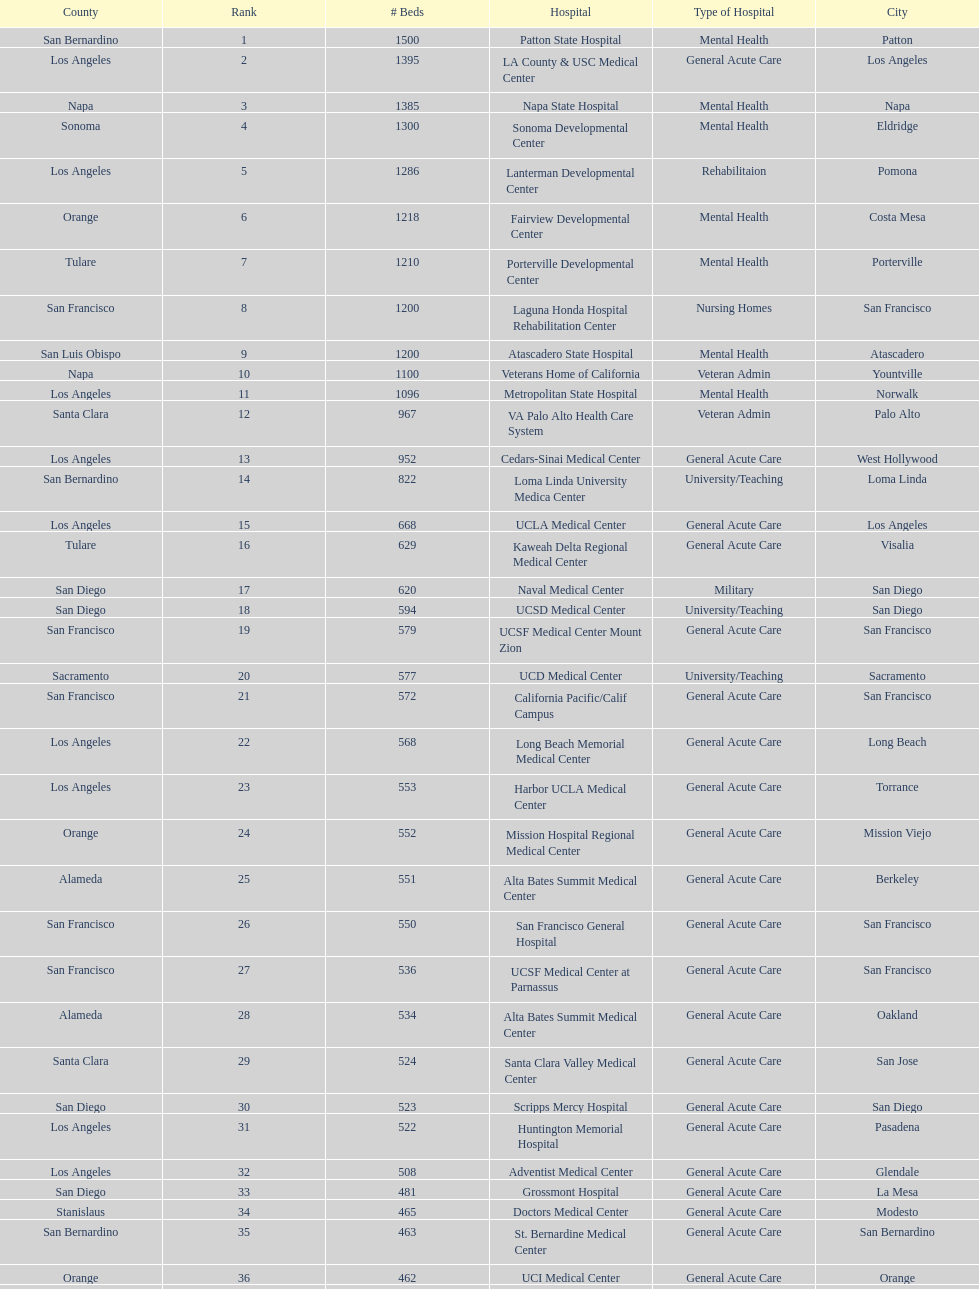Help me parse the entirety of this table. {'header': ['County', 'Rank', '# Beds', 'Hospital', 'Type of Hospital', 'City'], 'rows': [['San Bernardino', '1', '1500', 'Patton State Hospital', 'Mental Health', 'Patton'], ['Los Angeles', '2', '1395', 'LA County & USC Medical Center', 'General Acute Care', 'Los Angeles'], ['Napa', '3', '1385', 'Napa State Hospital', 'Mental Health', 'Napa'], ['Sonoma', '4', '1300', 'Sonoma Developmental Center', 'Mental Health', 'Eldridge'], ['Los Angeles', '5', '1286', 'Lanterman Developmental Center', 'Rehabilitaion', 'Pomona'], ['Orange', '6', '1218', 'Fairview Developmental Center', 'Mental Health', 'Costa Mesa'], ['Tulare', '7', '1210', 'Porterville Developmental Center', 'Mental Health', 'Porterville'], ['San Francisco', '8', '1200', 'Laguna Honda Hospital Rehabilitation Center', 'Nursing Homes', 'San Francisco'], ['San Luis Obispo', '9', '1200', 'Atascadero State Hospital', 'Mental Health', 'Atascadero'], ['Napa', '10', '1100', 'Veterans Home of California', 'Veteran Admin', 'Yountville'], ['Los Angeles', '11', '1096', 'Metropolitan State Hospital', 'Mental Health', 'Norwalk'], ['Santa Clara', '12', '967', 'VA Palo Alto Health Care System', 'Veteran Admin', 'Palo Alto'], ['Los Angeles', '13', '952', 'Cedars-Sinai Medical Center', 'General Acute Care', 'West Hollywood'], ['San Bernardino', '14', '822', 'Loma Linda University Medica Center', 'University/Teaching', 'Loma Linda'], ['Los Angeles', '15', '668', 'UCLA Medical Center', 'General Acute Care', 'Los Angeles'], ['Tulare', '16', '629', 'Kaweah Delta Regional Medical Center', 'General Acute Care', 'Visalia'], ['San Diego', '17', '620', 'Naval Medical Center', 'Military', 'San Diego'], ['San Diego', '18', '594', 'UCSD Medical Center', 'University/Teaching', 'San Diego'], ['San Francisco', '19', '579', 'UCSF Medical Center Mount Zion', 'General Acute Care', 'San Francisco'], ['Sacramento', '20', '577', 'UCD Medical Center', 'University/Teaching', 'Sacramento'], ['San Francisco', '21', '572', 'California Pacific/Calif Campus', 'General Acute Care', 'San Francisco'], ['Los Angeles', '22', '568', 'Long Beach Memorial Medical Center', 'General Acute Care', 'Long Beach'], ['Los Angeles', '23', '553', 'Harbor UCLA Medical Center', 'General Acute Care', 'Torrance'], ['Orange', '24', '552', 'Mission Hospital Regional Medical Center', 'General Acute Care', 'Mission Viejo'], ['Alameda', '25', '551', 'Alta Bates Summit Medical Center', 'General Acute Care', 'Berkeley'], ['San Francisco', '26', '550', 'San Francisco General Hospital', 'General Acute Care', 'San Francisco'], ['San Francisco', '27', '536', 'UCSF Medical Center at Parnassus', 'General Acute Care', 'San Francisco'], ['Alameda', '28', '534', 'Alta Bates Summit Medical Center', 'General Acute Care', 'Oakland'], ['Santa Clara', '29', '524', 'Santa Clara Valley Medical Center', 'General Acute Care', 'San Jose'], ['San Diego', '30', '523', 'Scripps Mercy Hospital', 'General Acute Care', 'San Diego'], ['Los Angeles', '31', '522', 'Huntington Memorial Hospital', 'General Acute Care', 'Pasadena'], ['Los Angeles', '32', '508', 'Adventist Medical Center', 'General Acute Care', 'Glendale'], ['San Diego', '33', '481', 'Grossmont Hospital', 'General Acute Care', 'La Mesa'], ['Stanislaus', '34', '465', 'Doctors Medical Center', 'General Acute Care', 'Modesto'], ['San Bernardino', '35', '463', 'St. Bernardine Medical Center', 'General Acute Care', 'San Bernardino'], ['Orange', '36', '462', 'UCI Medical Center', 'General Acute Care', 'Orange'], ['Santa Clara', '37', '460', 'Stanford Medical Center', 'General Acute Care', 'Stanford'], ['Fresno', '38', '457', 'Community Regional Medical Center', 'General Acute Care', 'Fresno'], ['Los Angeles', '39', '455', 'Methodist Hospital', 'General Acute Care', 'Arcadia'], ['Los Angeles', '40', '455', 'Providence St. Joseph Medical Center', 'General Acute Care', 'Burbank'], ['Orange', '41', '450', 'Hoag Memorial Hospital', 'General Acute Care', 'Newport Beach'], ['Santa Clara', '42', '450', 'Agnews Developmental Center', 'Mental Health', 'San Jose'], ['San Francisco', '43', '450', 'Jewish Home', 'Nursing Homes', 'San Francisco'], ['Orange', '44', '448', 'St. Joseph Hospital Orange', 'General Acute Care', 'Orange'], ['Los Angeles', '45', '441', 'Presbyterian Intercommunity', 'General Acute Care', 'Whittier'], ['San Bernardino', '46', '440', 'Kaiser Permanente Medical Center', 'General Acute Care', 'Fontana'], ['Los Angeles', '47', '439', 'Kaiser Permanente Medical Center', 'General Acute Care', 'Los Angeles'], ['Los Angeles', '48', '436', 'Pomona Valley Hospital Medical Center', 'General Acute Care', 'Pomona'], ['Sacramento', '49', '432', 'Sutter General Medical Center', 'General Acute Care', 'Sacramento'], ['San Francisco', '50', '430', 'St. Mary Medical Center', 'General Acute Care', 'San Francisco'], ['Santa Clara', '50', '429', 'Good Samaritan Hospital', 'General Acute Care', 'San Jose']]} How many hospitals have at least 1,000 beds? 11. 